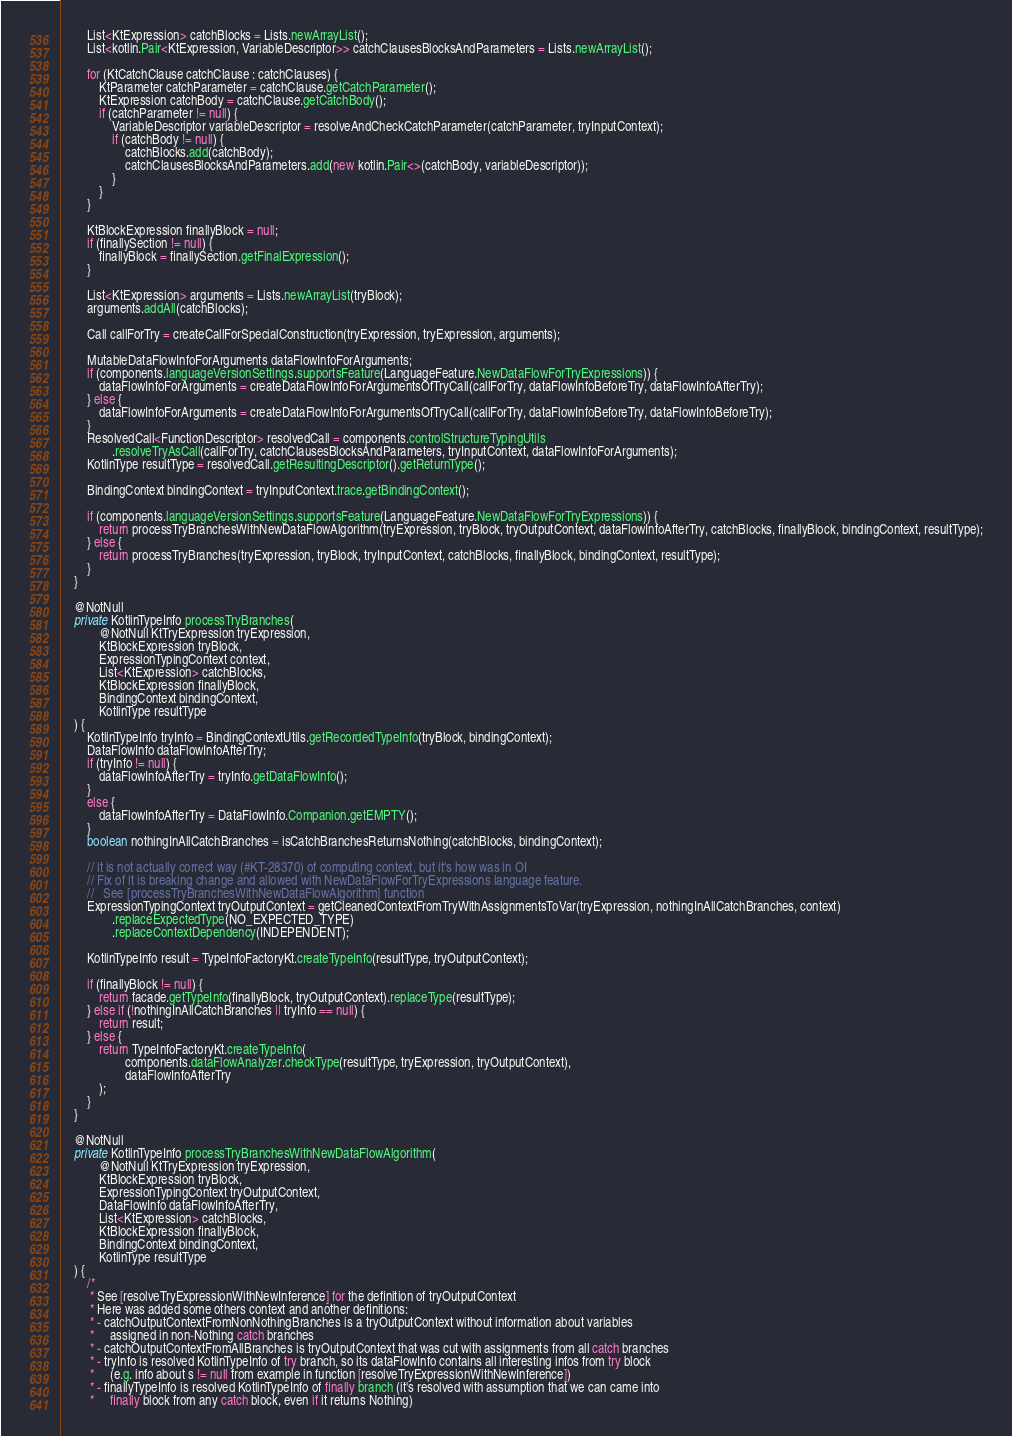Convert code to text. <code><loc_0><loc_0><loc_500><loc_500><_Java_>        List<KtExpression> catchBlocks = Lists.newArrayList();
        List<kotlin.Pair<KtExpression, VariableDescriptor>> catchClausesBlocksAndParameters = Lists.newArrayList();

        for (KtCatchClause catchClause : catchClauses) {
            KtParameter catchParameter = catchClause.getCatchParameter();
            KtExpression catchBody = catchClause.getCatchBody();
            if (catchParameter != null) {
                VariableDescriptor variableDescriptor = resolveAndCheckCatchParameter(catchParameter, tryInputContext);
                if (catchBody != null) {
                    catchBlocks.add(catchBody);
                    catchClausesBlocksAndParameters.add(new kotlin.Pair<>(catchBody, variableDescriptor));
                }
            }
        }

        KtBlockExpression finallyBlock = null;
        if (finallySection != null) {
            finallyBlock = finallySection.getFinalExpression();
        }

        List<KtExpression> arguments = Lists.newArrayList(tryBlock);
        arguments.addAll(catchBlocks);

        Call callForTry = createCallForSpecialConstruction(tryExpression, tryExpression, arguments);

        MutableDataFlowInfoForArguments dataFlowInfoForArguments;
        if (components.languageVersionSettings.supportsFeature(LanguageFeature.NewDataFlowForTryExpressions)) {
            dataFlowInfoForArguments = createDataFlowInfoForArgumentsOfTryCall(callForTry, dataFlowInfoBeforeTry, dataFlowInfoAfterTry);
        } else {
            dataFlowInfoForArguments = createDataFlowInfoForArgumentsOfTryCall(callForTry, dataFlowInfoBeforeTry, dataFlowInfoBeforeTry);
        }
        ResolvedCall<FunctionDescriptor> resolvedCall = components.controlStructureTypingUtils
                .resolveTryAsCall(callForTry, catchClausesBlocksAndParameters, tryInputContext, dataFlowInfoForArguments);
        KotlinType resultType = resolvedCall.getResultingDescriptor().getReturnType();

        BindingContext bindingContext = tryInputContext.trace.getBindingContext();

        if (components.languageVersionSettings.supportsFeature(LanguageFeature.NewDataFlowForTryExpressions)) {
            return processTryBranchesWithNewDataFlowAlgorithm(tryExpression, tryBlock, tryOutputContext, dataFlowInfoAfterTry, catchBlocks, finallyBlock, bindingContext, resultType);
        } else {
            return processTryBranches(tryExpression, tryBlock, tryInputContext, catchBlocks, finallyBlock, bindingContext, resultType);
        }
    }

    @NotNull
    private KotlinTypeInfo processTryBranches(
            @NotNull KtTryExpression tryExpression,
            KtBlockExpression tryBlock,
            ExpressionTypingContext context,
            List<KtExpression> catchBlocks,
            KtBlockExpression finallyBlock,
            BindingContext bindingContext,
            KotlinType resultType
    ) {
        KotlinTypeInfo tryInfo = BindingContextUtils.getRecordedTypeInfo(tryBlock, bindingContext);
        DataFlowInfo dataFlowInfoAfterTry;
        if (tryInfo != null) {
            dataFlowInfoAfterTry = tryInfo.getDataFlowInfo();
        }
        else {
            dataFlowInfoAfterTry = DataFlowInfo.Companion.getEMPTY();
        }
        boolean nothingInAllCatchBranches = isCatchBranchesReturnsNothing(catchBlocks, bindingContext);

        // it is not actually correct way (#KT-28370) of computing context, but it's how was in OI
        // Fix of it is breaking change and allowed with NewDataFlowForTryExpressions language feature.
        //   See [processTryBranchesWithNewDataFlowAlgorithm] function
        ExpressionTypingContext tryOutputContext = getCleanedContextFromTryWithAssignmentsToVar(tryExpression, nothingInAllCatchBranches, context)
                .replaceExpectedType(NO_EXPECTED_TYPE)
                .replaceContextDependency(INDEPENDENT);

        KotlinTypeInfo result = TypeInfoFactoryKt.createTypeInfo(resultType, tryOutputContext);

        if (finallyBlock != null) {
            return facade.getTypeInfo(finallyBlock, tryOutputContext).replaceType(resultType);
        } else if (!nothingInAllCatchBranches || tryInfo == null) {
            return result;
        } else {
            return TypeInfoFactoryKt.createTypeInfo(
                    components.dataFlowAnalyzer.checkType(resultType, tryExpression, tryOutputContext),
                    dataFlowInfoAfterTry
            );
        }
    }

    @NotNull
    private KotlinTypeInfo processTryBranchesWithNewDataFlowAlgorithm(
            @NotNull KtTryExpression tryExpression,
            KtBlockExpression tryBlock,
            ExpressionTypingContext tryOutputContext,
            DataFlowInfo dataFlowInfoAfterTry,
            List<KtExpression> catchBlocks,
            KtBlockExpression finallyBlock,
            BindingContext bindingContext,
            KotlinType resultType
    ) {
        /*
         * See [resolveTryExpressionWithNewInference] for the definition of tryOutputContext
         * Here was added some others context and another definitions:
         * - catchOutputContextFromNonNothingBranches is a tryOutputContext without information about variables
         *     assigned in non-Nothing catch branches
         * - catchOutputContextFromAllBranches is tryOutputContext that was cut with assignments from all catch branches
         * - tryInfo is resolved KotlinTypeInfo of try branch, so its dataFlowInfo contains all interesting infos from try block
         *     (e.g. info about s != null from example in function [resolveTryExpressionWithNewInference])
         * - finallyTypeInfo is resolved KotlinTypeInfo of finally branch (it's resolved with assumption that we can came into
         *     finally block from any catch block, even if it returns Nothing)</code> 